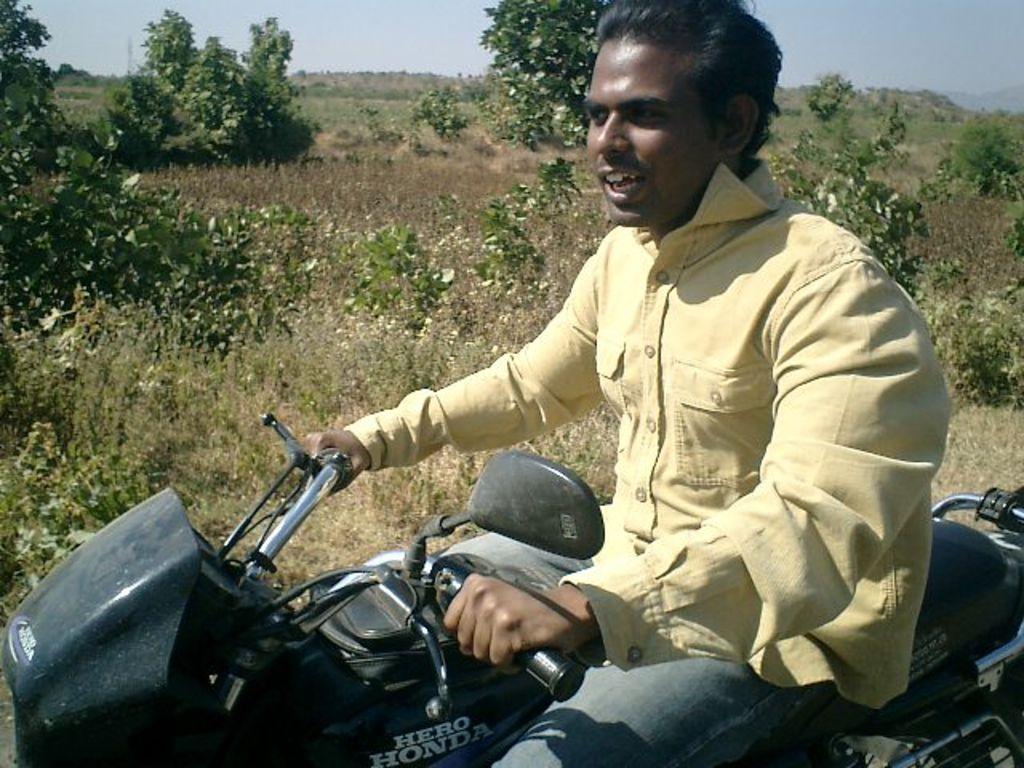In one or two sentences, can you explain what this image depicts? This man is riding a motorbike. Far there are number of trees. 